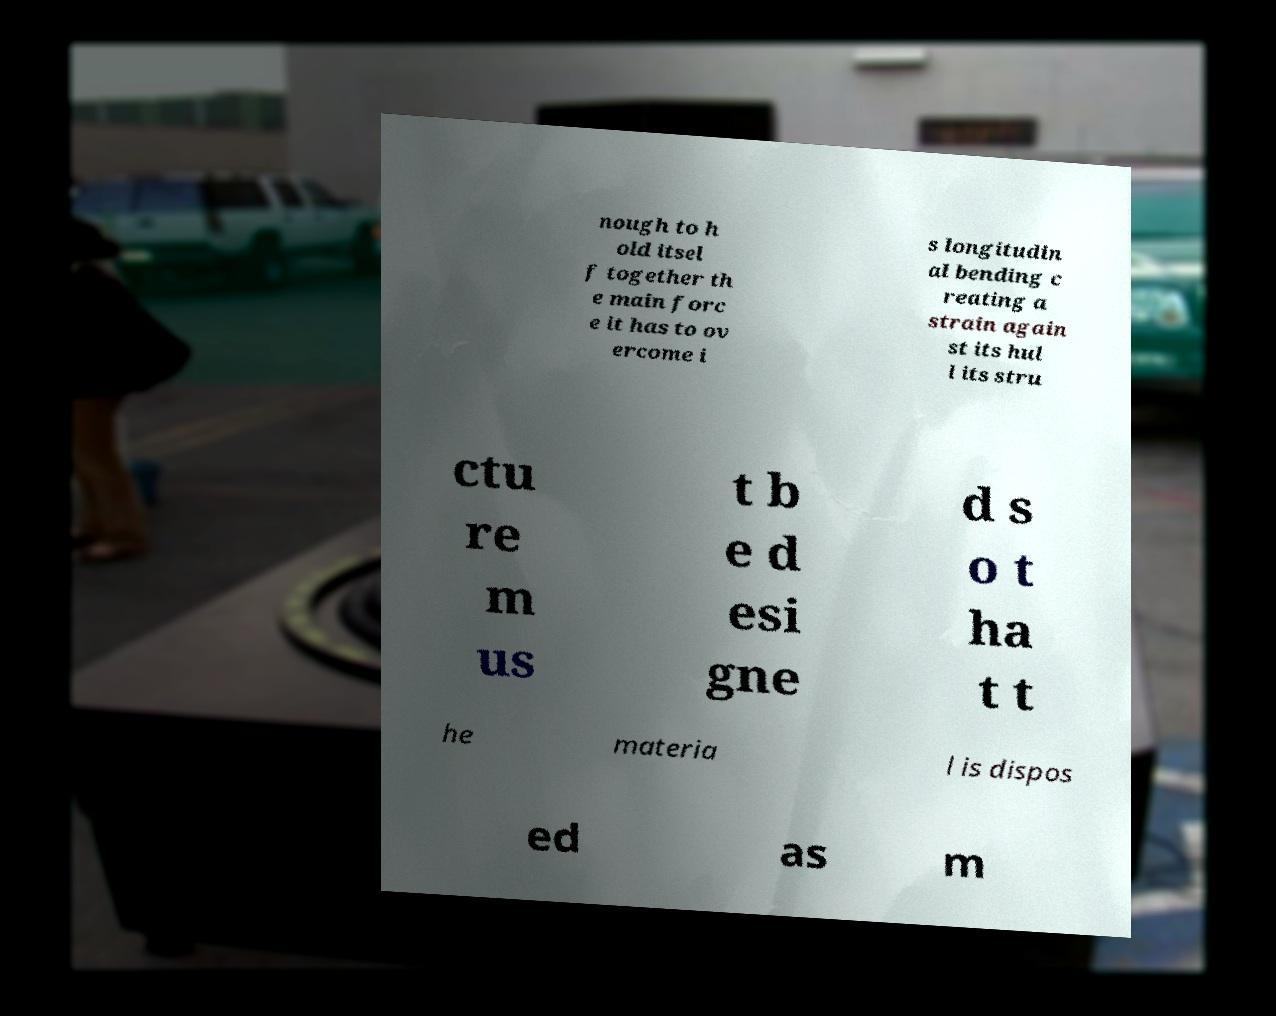Please read and relay the text visible in this image. What does it say? nough to h old itsel f together th e main forc e it has to ov ercome i s longitudin al bending c reating a strain again st its hul l its stru ctu re m us t b e d esi gne d s o t ha t t he materia l is dispos ed as m 